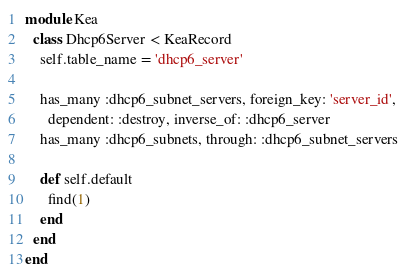Convert code to text. <code><loc_0><loc_0><loc_500><loc_500><_Ruby_>module Kea
  class Dhcp6Server < KeaRecord
    self.table_name = 'dhcp6_server'

    has_many :dhcp6_subnet_servers, foreign_key: 'server_id',
      dependent: :destroy, inverse_of: :dhcp6_server
    has_many :dhcp6_subnets, through: :dhcp6_subnet_servers

    def self.default
      find(1)
    end
  end
end
</code> 